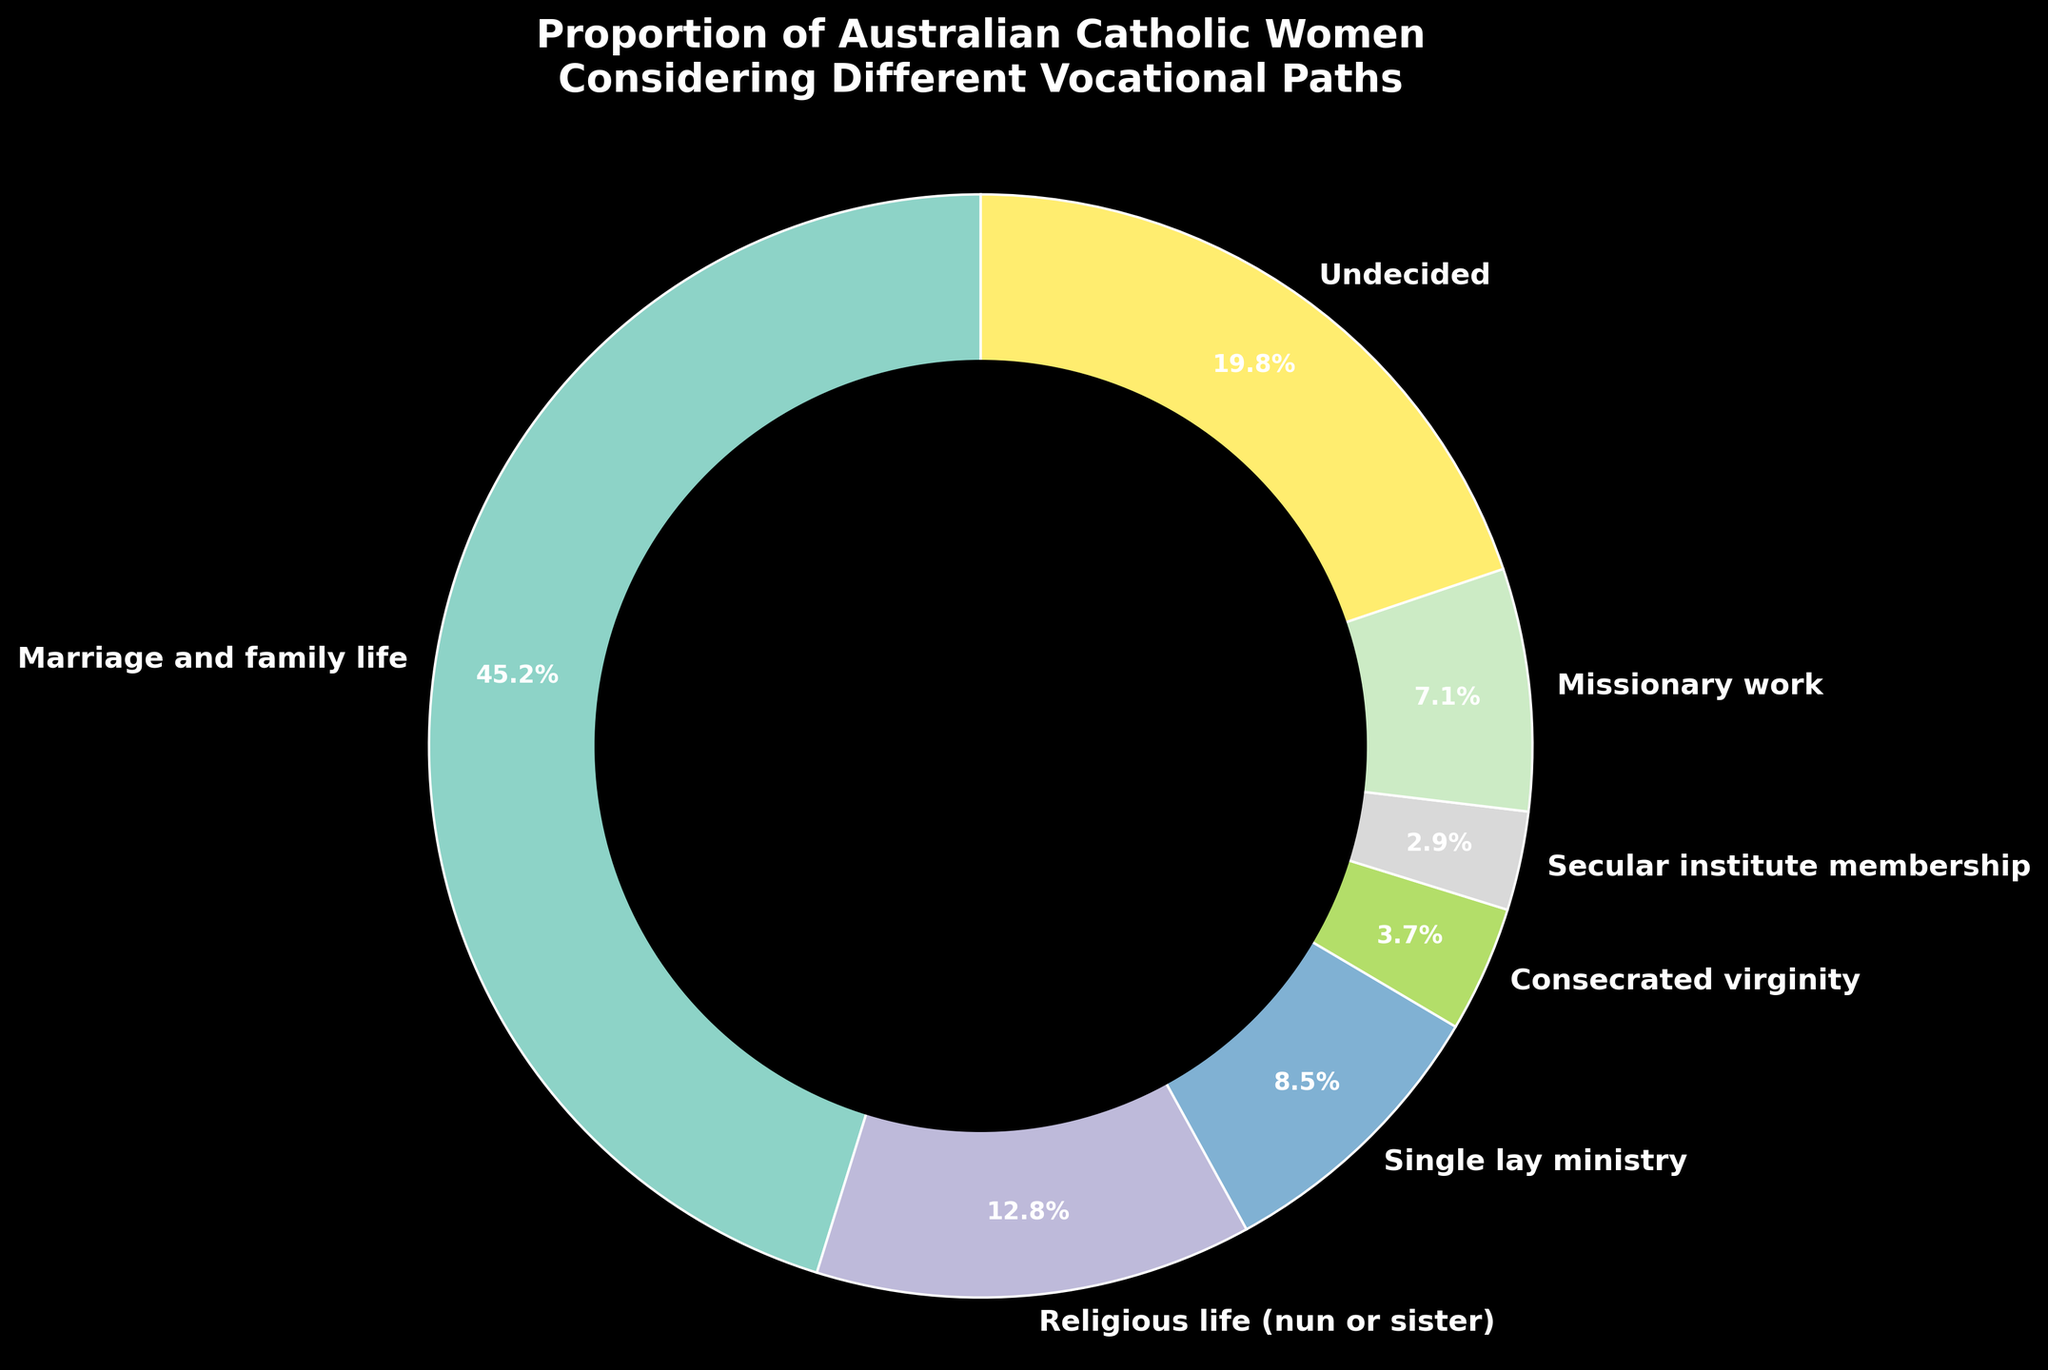What's the largest segment in the pie chart? The largest segment represents the Vocational Path with the highest percentage. By observing the figure, the largest segment is "Marriage and family life", which holds 45.2%.
Answer: Marriage and family life Which segment has the lowest proportion? The segment with the lowest proportion is the one with the smallest percentage. By looking at the figure, "Secular institute membership" has the smallest proportion with 2.9%.
Answer: Secular institute membership What is the total percentage of women considering religious or missionary work? To find the total percentage of women considering religious or missionary work, sum the percentages of 'Religious life (nun or sister)' and 'Missionary work'. That's 12.8% + 7.1% = 19.9%.
Answer: 19.9% How many categories have a percentage greater than 10%? To find the number of categories with a percentage greater than 10%, count the segments with values over 10%: "Marriage and family life" (45.2%) and "Religious life (nun or sister)" (12.8%). Two categories meet this criterion.
Answer: 2 Which category has a slightly larger proportion, 'Single lay ministry' or 'Missionary work'? By comparing the segments for 'Single lay ministry' and 'Missionary work', we see that 'Missionary work' has a slightly larger proportion (7.1%) compared to 'Single lay ministry' (8.5%).
Answer: Single lay ministry What's the combined percentage of women undecided or considering a single lay ministry? Sum the percentages of 'Undecided' and 'Single lay ministry'. That's 19.8% + 8.5% = 28.3%.
Answer: 28.3% Is the proportion of women considering 'Religious life (nun or sister)' more than twice the proportion of 'Consecrated virginity'? To determine if the proportion of women considering 'Religious life (nun or sister)' (12.8%) is more than twice that of 'Consecrated virginity' (3.7%), calculate 3.7% * 2 = 7.4%. Since 12.8% > 7.4%, the answer is yes.
Answer: Yes Which category occupies a visually prominent position but isn't the largest? Observing the size and position of the pie chart segments, 'Religious life (nun or sister)' (12.8%) is visually prominent but isn't the largest as 'Marriage and family life' (45.2%) is the largest.
Answer: Religious life (nun or sister) What is the difference in percentage between 'Marriage and family life' and 'Undecided'? Subtract the percentage of 'Undecided' from 'Marriage and family life'. That's 45.2% - 19.8% = 25.4%.
Answer: 25.4% Is the segment for 'Marriage and family life' larger than the combined segments for 'Undecided' and 'Single lay ministry'? To compare, sum 'Undecided' (19.8%) and 'Single lay ministry' (8.5%). Combined, they are 19.8% + 8.5% = 28.3%. Since 'Marriage and family life' is 45.2%, it's larger.
Answer: Yes 